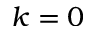Convert formula to latex. <formula><loc_0><loc_0><loc_500><loc_500>k = 0</formula> 